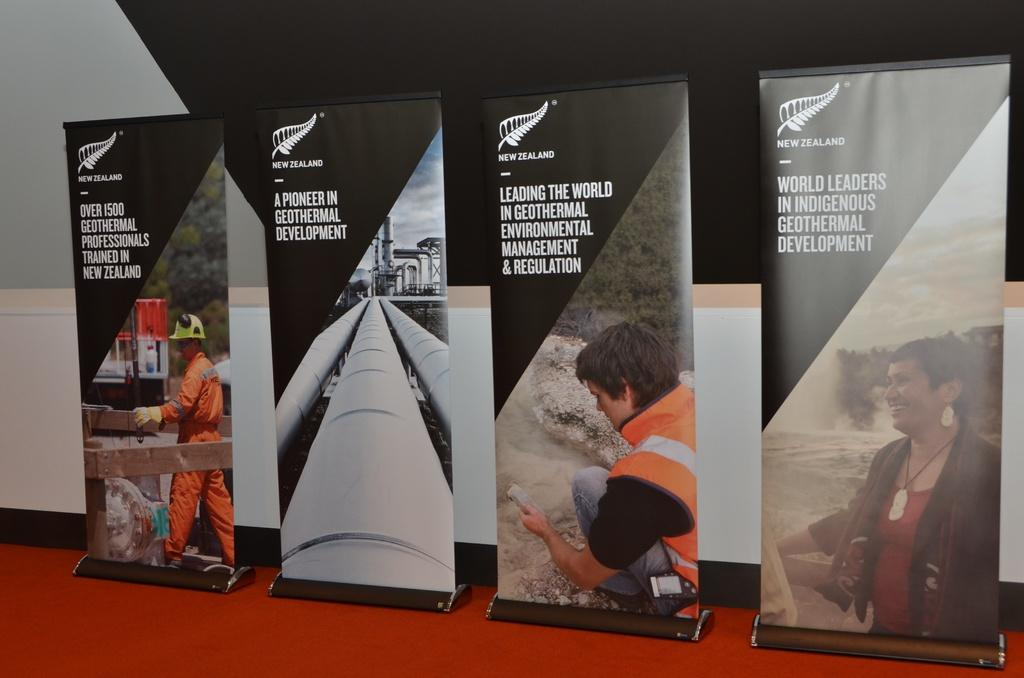<image>
Provide a brief description of the given image. Four vertical signs for geothermal development in New Zealand. 